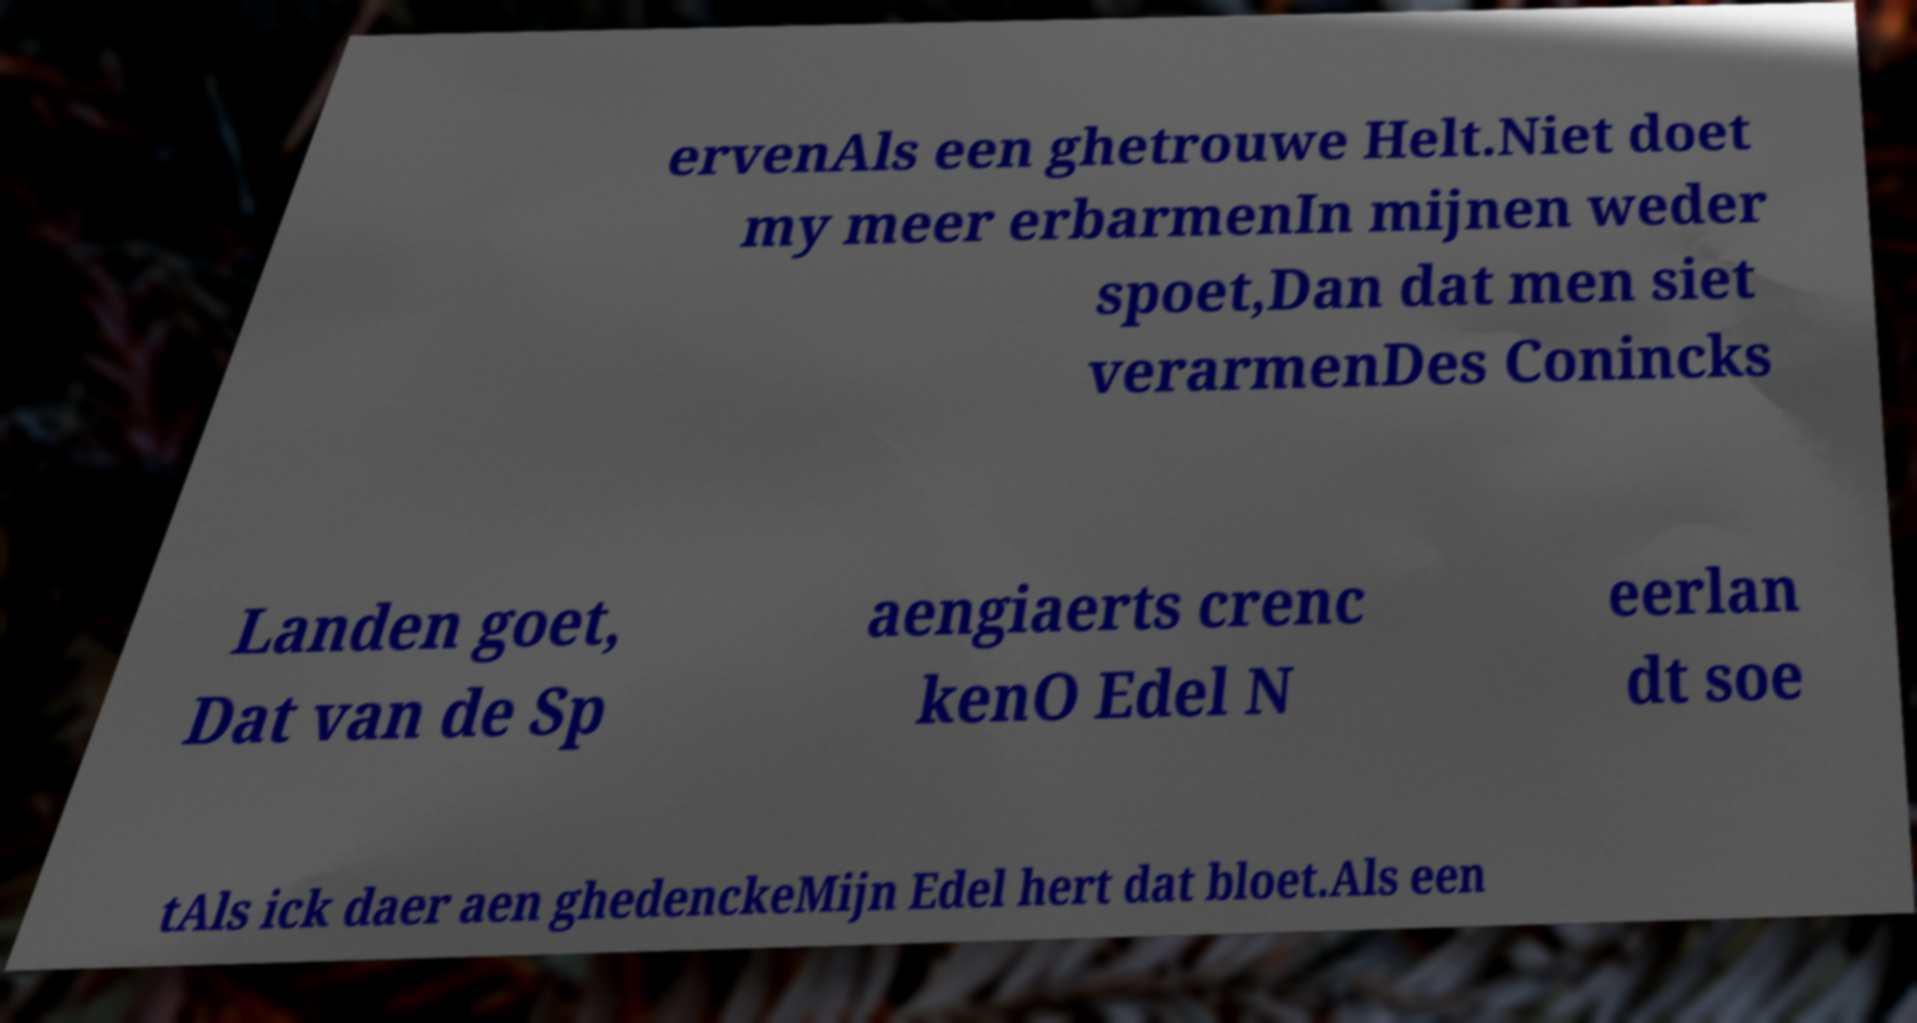What messages or text are displayed in this image? I need them in a readable, typed format. ervenAls een ghetrouwe Helt.Niet doet my meer erbarmenIn mijnen weder spoet,Dan dat men siet verarmenDes Conincks Landen goet, Dat van de Sp aengiaerts crenc kenO Edel N eerlan dt soe tAls ick daer aen ghedenckeMijn Edel hert dat bloet.Als een 